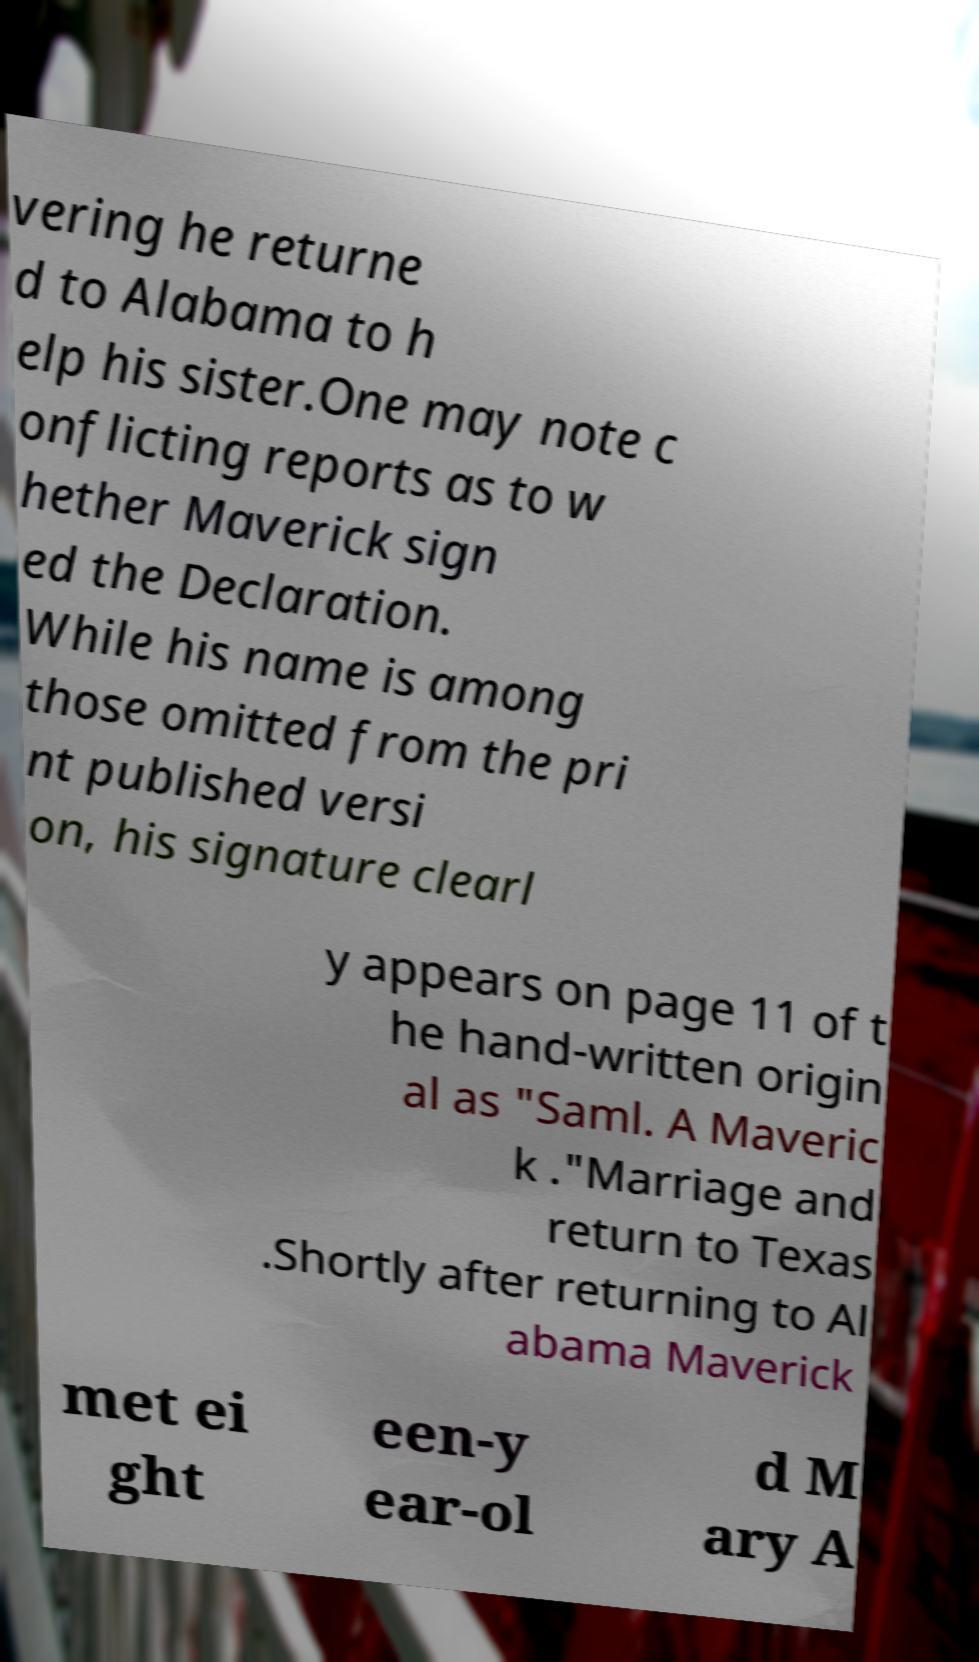Can you read and provide the text displayed in the image?This photo seems to have some interesting text. Can you extract and type it out for me? vering he returne d to Alabama to h elp his sister.One may note c onflicting reports as to w hether Maverick sign ed the Declaration. While his name is among those omitted from the pri nt published versi on, his signature clearl y appears on page 11 of t he hand-written origin al as "Saml. A Maveric k ."Marriage and return to Texas .Shortly after returning to Al abama Maverick met ei ght een-y ear-ol d M ary A 